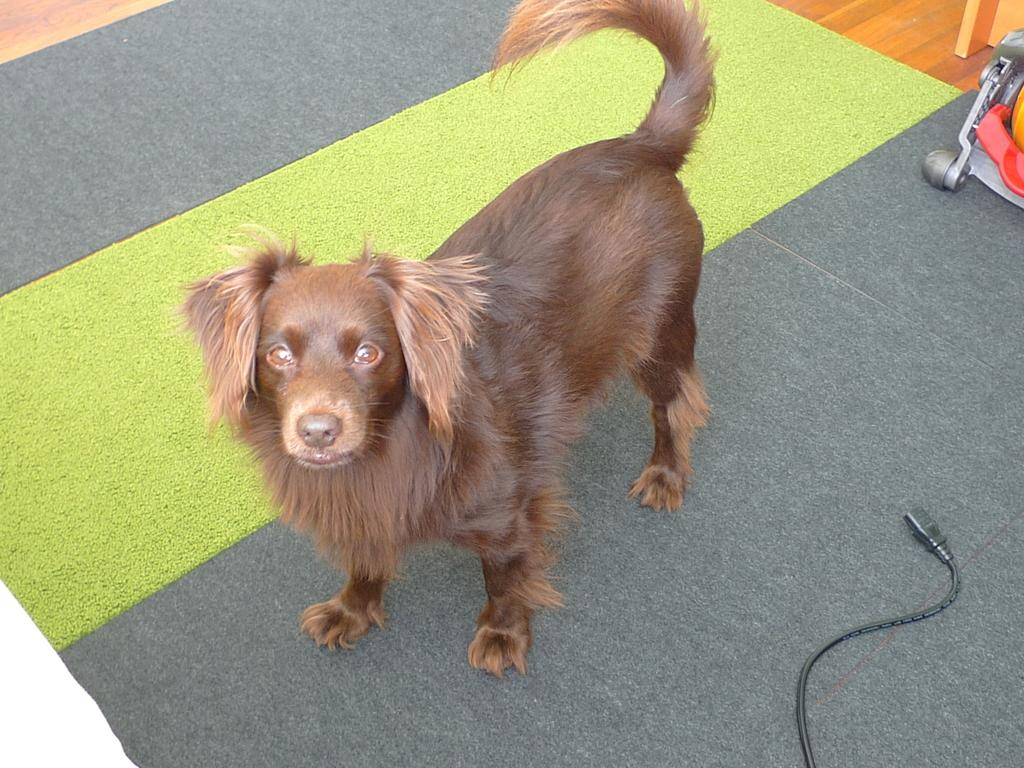What type of animal is in the image? There is a dog in the image. Where is the dog located in the image? The dog is standing on the floor. What else can be seen in the image besides the dog? There is a wire visible in the image. How many children are playing with the dog in the image? There are no children present in the image; it only features a dog standing on the floor. Is there a sink visible in the image? There is no sink present in the image. 